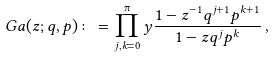<formula> <loc_0><loc_0><loc_500><loc_500>\ G a ( z ; q , p ) \colon = \prod _ { j , k = 0 } ^ { \i } y \frac { 1 - z ^ { - 1 } q ^ { j + 1 } p ^ { k + 1 } } { 1 - z q ^ { j } p ^ { k } } \, ,</formula> 